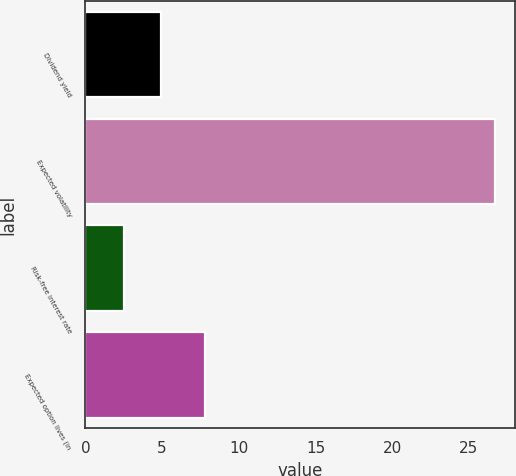<chart> <loc_0><loc_0><loc_500><loc_500><bar_chart><fcel>Dividend yield<fcel>Expected volatility<fcel>Risk-free interest rate<fcel>Expected option lives (in<nl><fcel>4.91<fcel>26.7<fcel>2.49<fcel>7.8<nl></chart> 